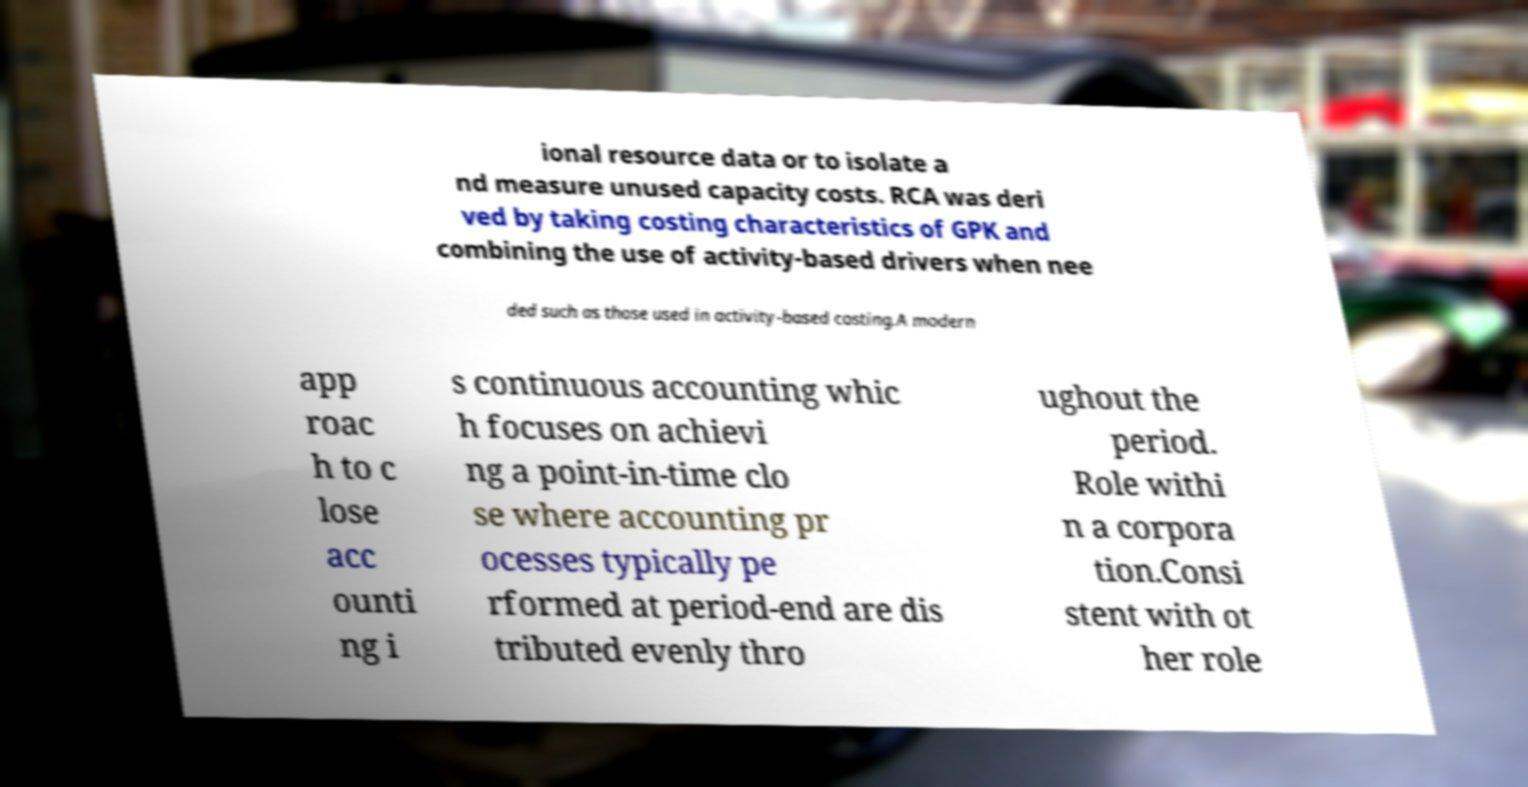For documentation purposes, I need the text within this image transcribed. Could you provide that? ional resource data or to isolate a nd measure unused capacity costs. RCA was deri ved by taking costing characteristics of GPK and combining the use of activity-based drivers when nee ded such as those used in activity-based costing.A modern app roac h to c lose acc ounti ng i s continuous accounting whic h focuses on achievi ng a point-in-time clo se where accounting pr ocesses typically pe rformed at period-end are dis tributed evenly thro ughout the period. Role withi n a corpora tion.Consi stent with ot her role 